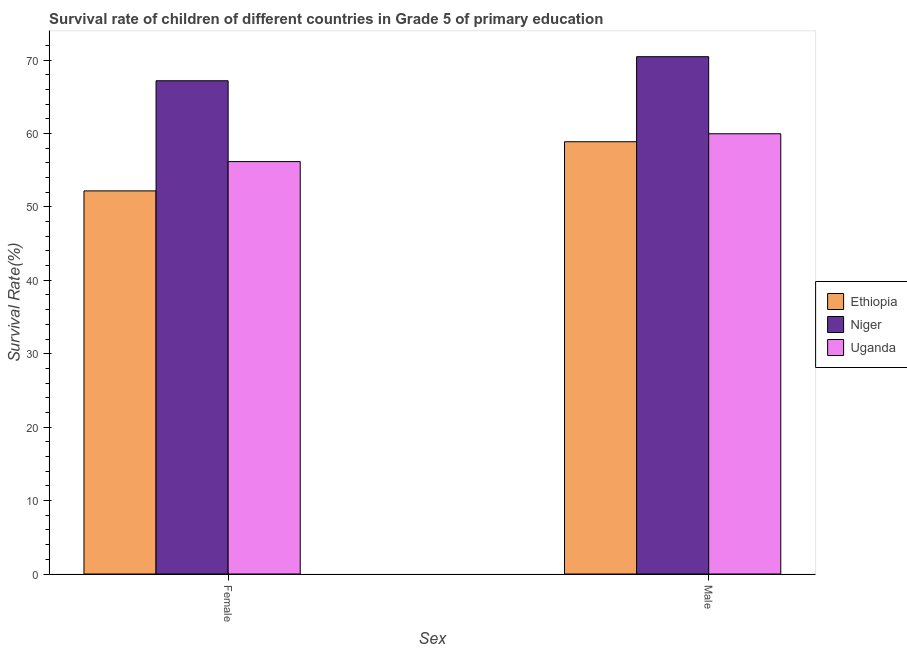How many different coloured bars are there?
Your answer should be very brief. 3. How many groups of bars are there?
Your answer should be very brief. 2. Are the number of bars on each tick of the X-axis equal?
Your answer should be compact. Yes. How many bars are there on the 1st tick from the left?
Give a very brief answer. 3. How many bars are there on the 1st tick from the right?
Your response must be concise. 3. What is the survival rate of female students in primary education in Ethiopia?
Give a very brief answer. 52.18. Across all countries, what is the maximum survival rate of male students in primary education?
Ensure brevity in your answer.  70.46. Across all countries, what is the minimum survival rate of female students in primary education?
Your response must be concise. 52.18. In which country was the survival rate of male students in primary education maximum?
Offer a very short reply. Niger. In which country was the survival rate of male students in primary education minimum?
Provide a short and direct response. Ethiopia. What is the total survival rate of male students in primary education in the graph?
Provide a short and direct response. 189.29. What is the difference between the survival rate of male students in primary education in Niger and that in Uganda?
Provide a succinct answer. 10.5. What is the difference between the survival rate of female students in primary education in Ethiopia and the survival rate of male students in primary education in Uganda?
Ensure brevity in your answer.  -7.78. What is the average survival rate of female students in primary education per country?
Offer a very short reply. 58.51. What is the difference between the survival rate of male students in primary education and survival rate of female students in primary education in Ethiopia?
Offer a terse response. 6.69. In how many countries, is the survival rate of male students in primary education greater than 66 %?
Your answer should be very brief. 1. What is the ratio of the survival rate of female students in primary education in Niger to that in Uganda?
Your response must be concise. 1.2. In how many countries, is the survival rate of male students in primary education greater than the average survival rate of male students in primary education taken over all countries?
Keep it short and to the point. 1. What does the 3rd bar from the left in Male represents?
Your answer should be compact. Uganda. What does the 3rd bar from the right in Female represents?
Your answer should be very brief. Ethiopia. Does the graph contain grids?
Give a very brief answer. No. Where does the legend appear in the graph?
Ensure brevity in your answer.  Center right. How many legend labels are there?
Keep it short and to the point. 3. What is the title of the graph?
Ensure brevity in your answer.  Survival rate of children of different countries in Grade 5 of primary education. What is the label or title of the X-axis?
Your answer should be compact. Sex. What is the label or title of the Y-axis?
Provide a succinct answer. Survival Rate(%). What is the Survival Rate(%) of Ethiopia in Female?
Provide a succinct answer. 52.18. What is the Survival Rate(%) of Niger in Female?
Provide a succinct answer. 67.18. What is the Survival Rate(%) in Uganda in Female?
Keep it short and to the point. 56.17. What is the Survival Rate(%) of Ethiopia in Male?
Ensure brevity in your answer.  58.87. What is the Survival Rate(%) in Niger in Male?
Ensure brevity in your answer.  70.46. What is the Survival Rate(%) in Uganda in Male?
Your answer should be very brief. 59.96. Across all Sex, what is the maximum Survival Rate(%) in Ethiopia?
Your response must be concise. 58.87. Across all Sex, what is the maximum Survival Rate(%) in Niger?
Give a very brief answer. 70.46. Across all Sex, what is the maximum Survival Rate(%) of Uganda?
Offer a very short reply. 59.96. Across all Sex, what is the minimum Survival Rate(%) in Ethiopia?
Your response must be concise. 52.18. Across all Sex, what is the minimum Survival Rate(%) of Niger?
Keep it short and to the point. 67.18. Across all Sex, what is the minimum Survival Rate(%) in Uganda?
Your answer should be compact. 56.17. What is the total Survival Rate(%) of Ethiopia in the graph?
Your answer should be compact. 111.05. What is the total Survival Rate(%) of Niger in the graph?
Provide a short and direct response. 137.63. What is the total Survival Rate(%) in Uganda in the graph?
Provide a short and direct response. 116.13. What is the difference between the Survival Rate(%) in Ethiopia in Female and that in Male?
Give a very brief answer. -6.69. What is the difference between the Survival Rate(%) in Niger in Female and that in Male?
Ensure brevity in your answer.  -3.28. What is the difference between the Survival Rate(%) of Uganda in Female and that in Male?
Make the answer very short. -3.79. What is the difference between the Survival Rate(%) in Ethiopia in Female and the Survival Rate(%) in Niger in Male?
Offer a terse response. -18.28. What is the difference between the Survival Rate(%) in Ethiopia in Female and the Survival Rate(%) in Uganda in Male?
Ensure brevity in your answer.  -7.78. What is the difference between the Survival Rate(%) of Niger in Female and the Survival Rate(%) of Uganda in Male?
Keep it short and to the point. 7.22. What is the average Survival Rate(%) of Ethiopia per Sex?
Your response must be concise. 55.52. What is the average Survival Rate(%) of Niger per Sex?
Your answer should be very brief. 68.82. What is the average Survival Rate(%) in Uganda per Sex?
Provide a short and direct response. 58.06. What is the difference between the Survival Rate(%) of Ethiopia and Survival Rate(%) of Niger in Female?
Ensure brevity in your answer.  -15. What is the difference between the Survival Rate(%) in Ethiopia and Survival Rate(%) in Uganda in Female?
Give a very brief answer. -3.99. What is the difference between the Survival Rate(%) of Niger and Survival Rate(%) of Uganda in Female?
Ensure brevity in your answer.  11.01. What is the difference between the Survival Rate(%) of Ethiopia and Survival Rate(%) of Niger in Male?
Provide a short and direct response. -11.58. What is the difference between the Survival Rate(%) in Ethiopia and Survival Rate(%) in Uganda in Male?
Offer a very short reply. -1.09. What is the difference between the Survival Rate(%) of Niger and Survival Rate(%) of Uganda in Male?
Your answer should be very brief. 10.5. What is the ratio of the Survival Rate(%) of Ethiopia in Female to that in Male?
Ensure brevity in your answer.  0.89. What is the ratio of the Survival Rate(%) of Niger in Female to that in Male?
Offer a terse response. 0.95. What is the ratio of the Survival Rate(%) in Uganda in Female to that in Male?
Your answer should be compact. 0.94. What is the difference between the highest and the second highest Survival Rate(%) of Ethiopia?
Offer a very short reply. 6.69. What is the difference between the highest and the second highest Survival Rate(%) of Niger?
Provide a succinct answer. 3.28. What is the difference between the highest and the second highest Survival Rate(%) in Uganda?
Provide a short and direct response. 3.79. What is the difference between the highest and the lowest Survival Rate(%) of Ethiopia?
Your response must be concise. 6.69. What is the difference between the highest and the lowest Survival Rate(%) of Niger?
Keep it short and to the point. 3.28. What is the difference between the highest and the lowest Survival Rate(%) of Uganda?
Keep it short and to the point. 3.79. 